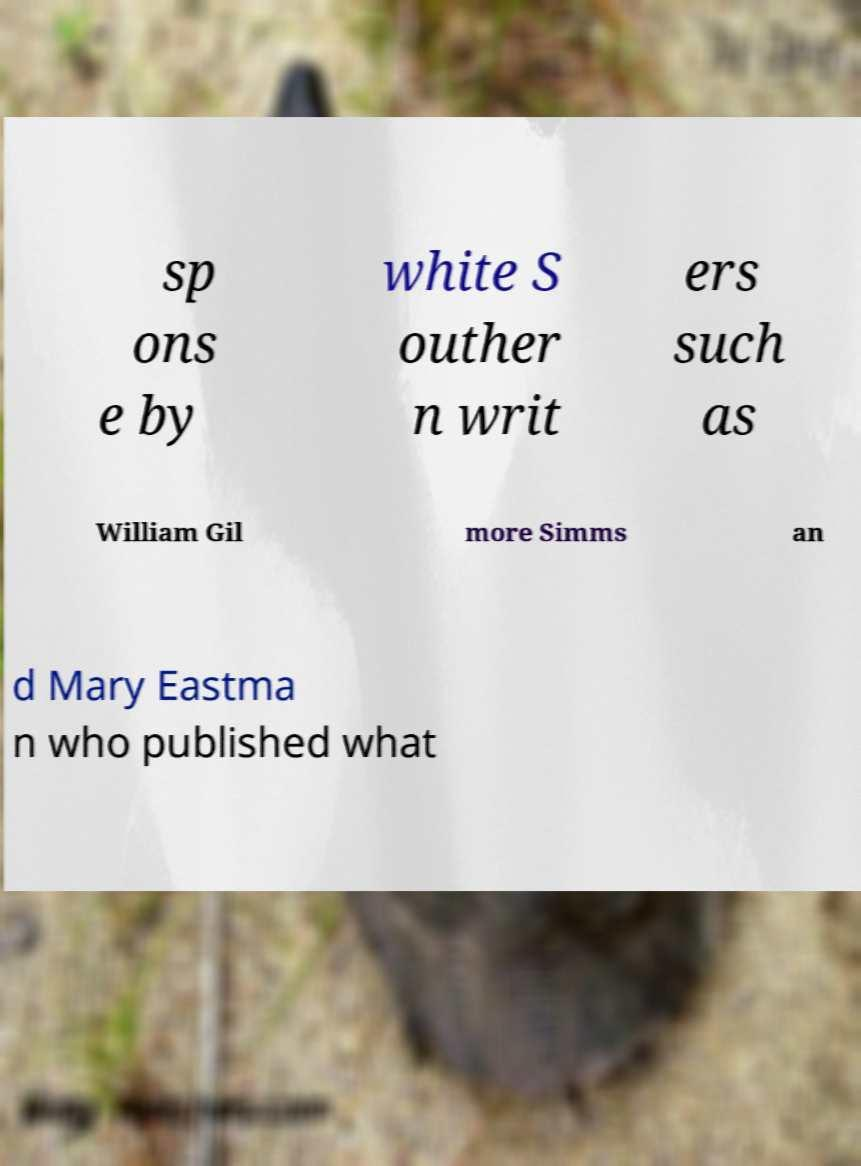I need the written content from this picture converted into text. Can you do that? sp ons e by white S outher n writ ers such as William Gil more Simms an d Mary Eastma n who published what 